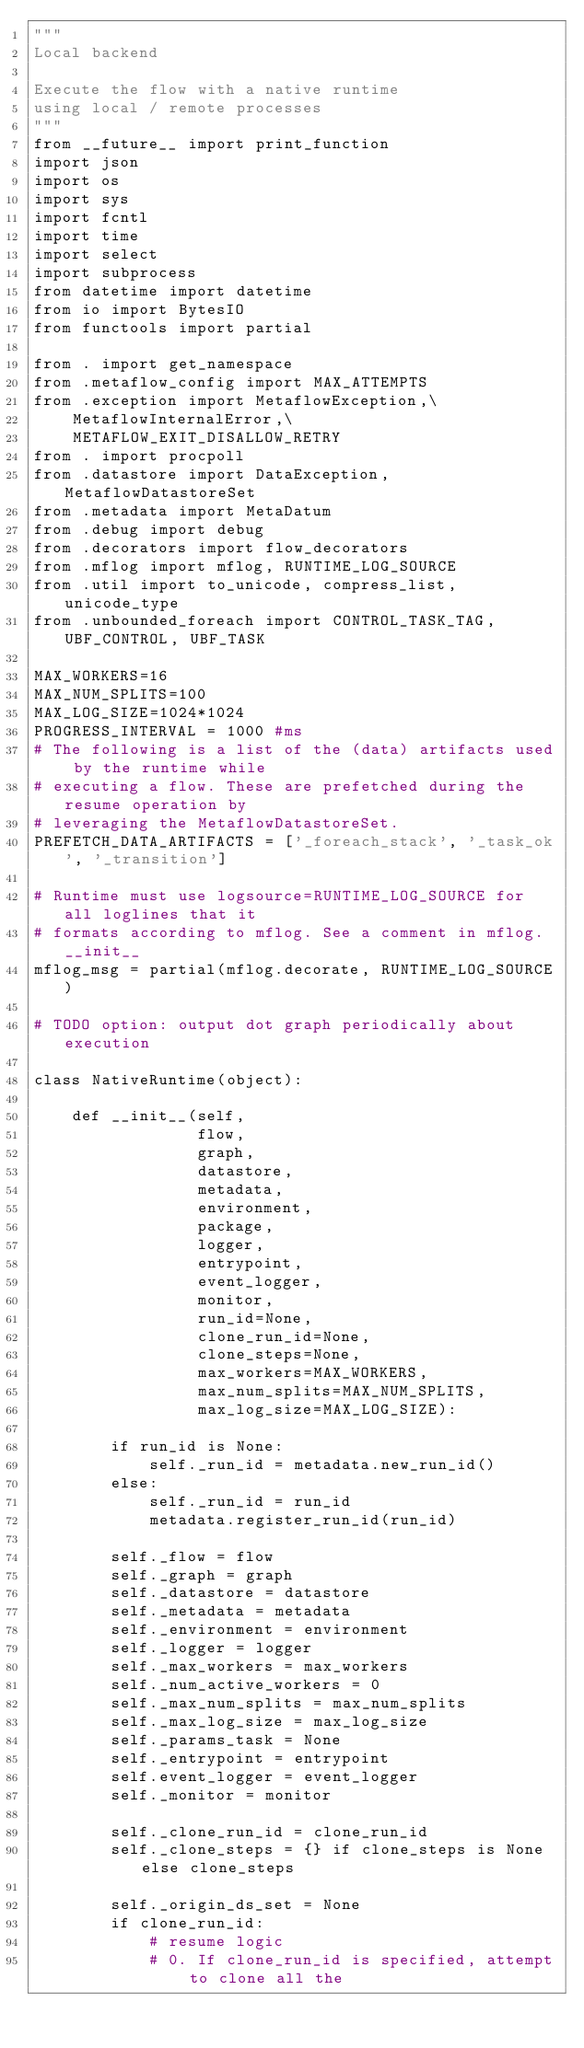Convert code to text. <code><loc_0><loc_0><loc_500><loc_500><_Python_>"""
Local backend

Execute the flow with a native runtime
using local / remote processes
"""
from __future__ import print_function
import json
import os
import sys
import fcntl
import time
import select
import subprocess
from datetime import datetime
from io import BytesIO
from functools import partial

from . import get_namespace
from .metaflow_config import MAX_ATTEMPTS
from .exception import MetaflowException,\
    MetaflowInternalError,\
    METAFLOW_EXIT_DISALLOW_RETRY
from . import procpoll
from .datastore import DataException, MetaflowDatastoreSet
from .metadata import MetaDatum
from .debug import debug
from .decorators import flow_decorators
from .mflog import mflog, RUNTIME_LOG_SOURCE
from .util import to_unicode, compress_list, unicode_type
from .unbounded_foreach import CONTROL_TASK_TAG, UBF_CONTROL, UBF_TASK

MAX_WORKERS=16
MAX_NUM_SPLITS=100
MAX_LOG_SIZE=1024*1024
PROGRESS_INTERVAL = 1000 #ms
# The following is a list of the (data) artifacts used by the runtime while
# executing a flow. These are prefetched during the resume operation by
# leveraging the MetaflowDatastoreSet.
PREFETCH_DATA_ARTIFACTS = ['_foreach_stack', '_task_ok', '_transition']

# Runtime must use logsource=RUNTIME_LOG_SOURCE for all loglines that it
# formats according to mflog. See a comment in mflog.__init__
mflog_msg = partial(mflog.decorate, RUNTIME_LOG_SOURCE)

# TODO option: output dot graph periodically about execution

class NativeRuntime(object):

    def __init__(self,
                 flow,
                 graph,
                 datastore,
                 metadata,
                 environment,
                 package,
                 logger,
                 entrypoint,
                 event_logger,
                 monitor,
                 run_id=None,
                 clone_run_id=None,
                 clone_steps=None,
                 max_workers=MAX_WORKERS,
                 max_num_splits=MAX_NUM_SPLITS,
                 max_log_size=MAX_LOG_SIZE):

        if run_id is None:
            self._run_id = metadata.new_run_id()
        else:
            self._run_id = run_id
            metadata.register_run_id(run_id)

        self._flow = flow
        self._graph = graph
        self._datastore = datastore
        self._metadata = metadata
        self._environment = environment
        self._logger = logger
        self._max_workers = max_workers
        self._num_active_workers = 0
        self._max_num_splits = max_num_splits
        self._max_log_size = max_log_size
        self._params_task = None
        self._entrypoint = entrypoint
        self.event_logger = event_logger
        self._monitor = monitor

        self._clone_run_id = clone_run_id
        self._clone_steps = {} if clone_steps is None else clone_steps

        self._origin_ds_set = None
        if clone_run_id:
            # resume logic
            # 0. If clone_run_id is specified, attempt to clone all the</code> 